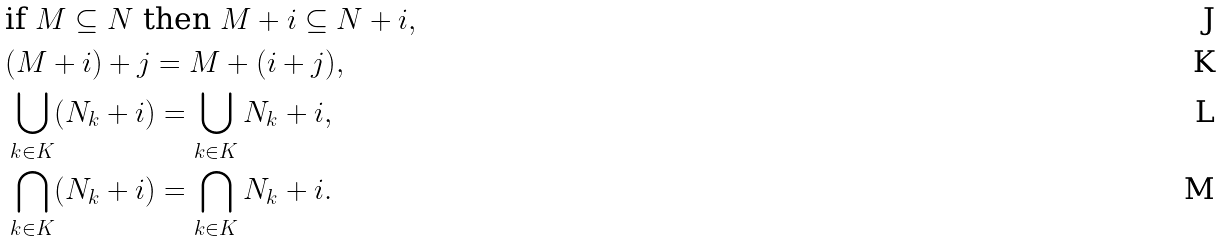Convert formula to latex. <formula><loc_0><loc_0><loc_500><loc_500>& \text {if } M \subseteq N \text { then } M + i \subseteq N + i , \\ & ( M + i ) + j = M + ( i + j ) , \\ & \bigcup _ { k \in K } ( N _ { k } + i ) = \bigcup _ { k \in K } N _ { k } + i , \\ & \bigcap _ { k \in K } ( N _ { k } + i ) = \bigcap _ { k \in K } N _ { k } + i .</formula> 